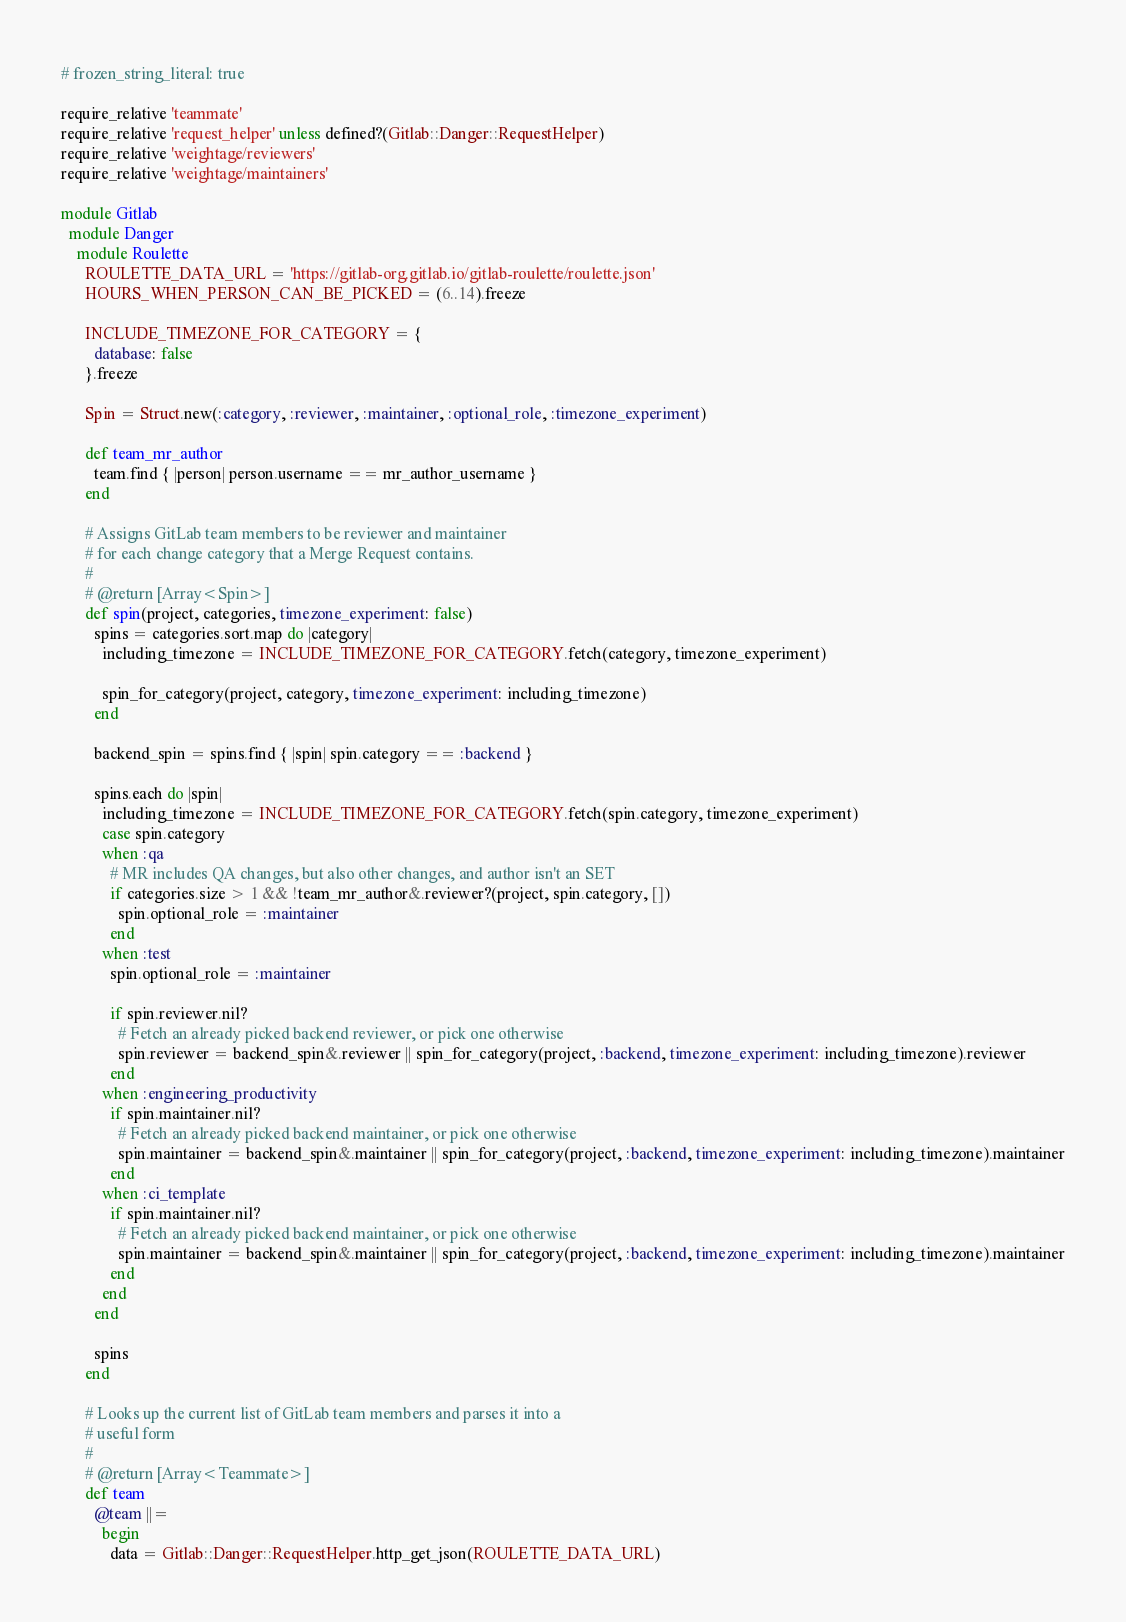Convert code to text. <code><loc_0><loc_0><loc_500><loc_500><_Ruby_># frozen_string_literal: true

require_relative 'teammate'
require_relative 'request_helper' unless defined?(Gitlab::Danger::RequestHelper)
require_relative 'weightage/reviewers'
require_relative 'weightage/maintainers'

module Gitlab
  module Danger
    module Roulette
      ROULETTE_DATA_URL = 'https://gitlab-org.gitlab.io/gitlab-roulette/roulette.json'
      HOURS_WHEN_PERSON_CAN_BE_PICKED = (6..14).freeze

      INCLUDE_TIMEZONE_FOR_CATEGORY = {
        database: false
      }.freeze

      Spin = Struct.new(:category, :reviewer, :maintainer, :optional_role, :timezone_experiment)

      def team_mr_author
        team.find { |person| person.username == mr_author_username }
      end

      # Assigns GitLab team members to be reviewer and maintainer
      # for each change category that a Merge Request contains.
      #
      # @return [Array<Spin>]
      def spin(project, categories, timezone_experiment: false)
        spins = categories.sort.map do |category|
          including_timezone = INCLUDE_TIMEZONE_FOR_CATEGORY.fetch(category, timezone_experiment)

          spin_for_category(project, category, timezone_experiment: including_timezone)
        end

        backend_spin = spins.find { |spin| spin.category == :backend }

        spins.each do |spin|
          including_timezone = INCLUDE_TIMEZONE_FOR_CATEGORY.fetch(spin.category, timezone_experiment)
          case spin.category
          when :qa
            # MR includes QA changes, but also other changes, and author isn't an SET
            if categories.size > 1 && !team_mr_author&.reviewer?(project, spin.category, [])
              spin.optional_role = :maintainer
            end
          when :test
            spin.optional_role = :maintainer

            if spin.reviewer.nil?
              # Fetch an already picked backend reviewer, or pick one otherwise
              spin.reviewer = backend_spin&.reviewer || spin_for_category(project, :backend, timezone_experiment: including_timezone).reviewer
            end
          when :engineering_productivity
            if spin.maintainer.nil?
              # Fetch an already picked backend maintainer, or pick one otherwise
              spin.maintainer = backend_spin&.maintainer || spin_for_category(project, :backend, timezone_experiment: including_timezone).maintainer
            end
          when :ci_template
            if spin.maintainer.nil?
              # Fetch an already picked backend maintainer, or pick one otherwise
              spin.maintainer = backend_spin&.maintainer || spin_for_category(project, :backend, timezone_experiment: including_timezone).maintainer
            end
          end
        end

        spins
      end

      # Looks up the current list of GitLab team members and parses it into a
      # useful form
      #
      # @return [Array<Teammate>]
      def team
        @team ||=
          begin
            data = Gitlab::Danger::RequestHelper.http_get_json(ROULETTE_DATA_URL)</code> 